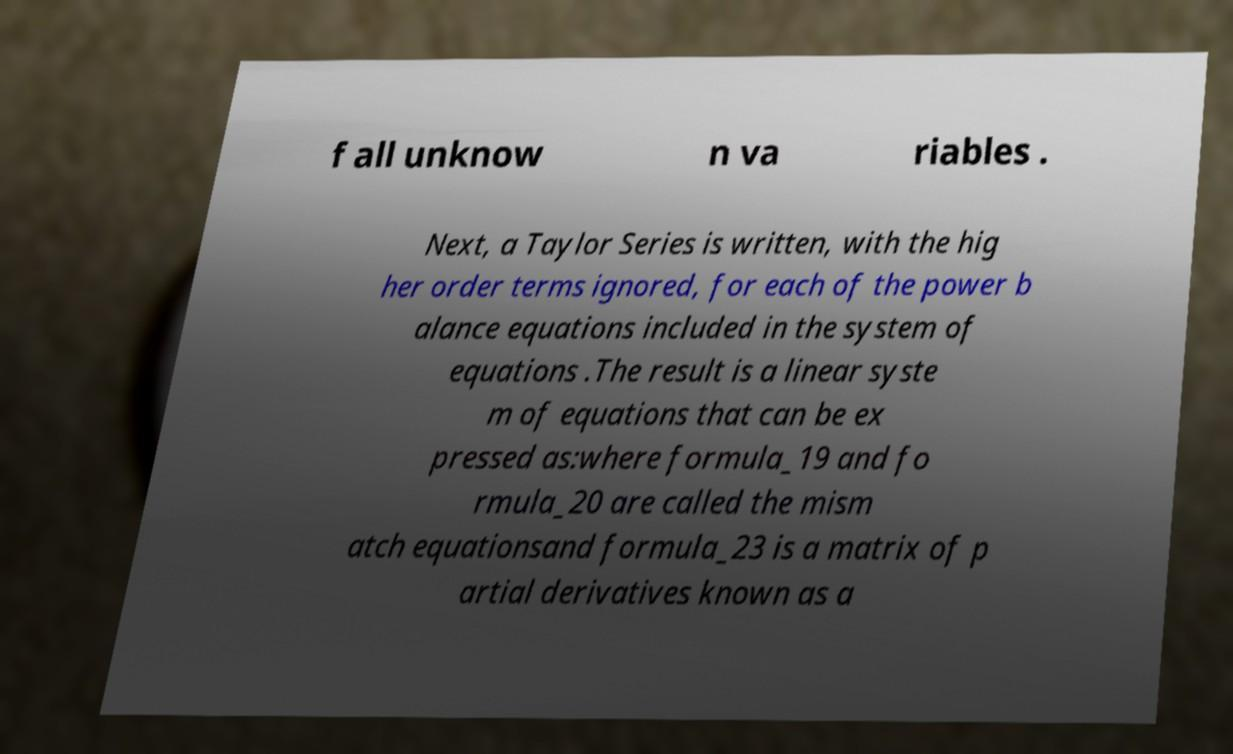Please identify and transcribe the text found in this image. f all unknow n va riables . Next, a Taylor Series is written, with the hig her order terms ignored, for each of the power b alance equations included in the system of equations .The result is a linear syste m of equations that can be ex pressed as:where formula_19 and fo rmula_20 are called the mism atch equationsand formula_23 is a matrix of p artial derivatives known as a 